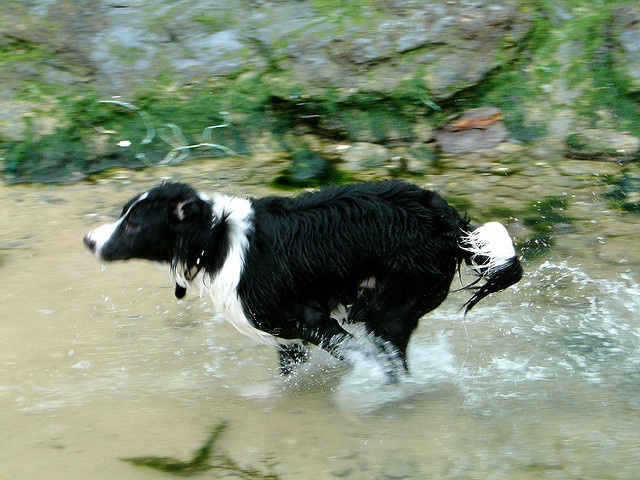Describe the objects in this image and their specific colors. I can see a dog in gray, black, white, and darkgray tones in this image. 